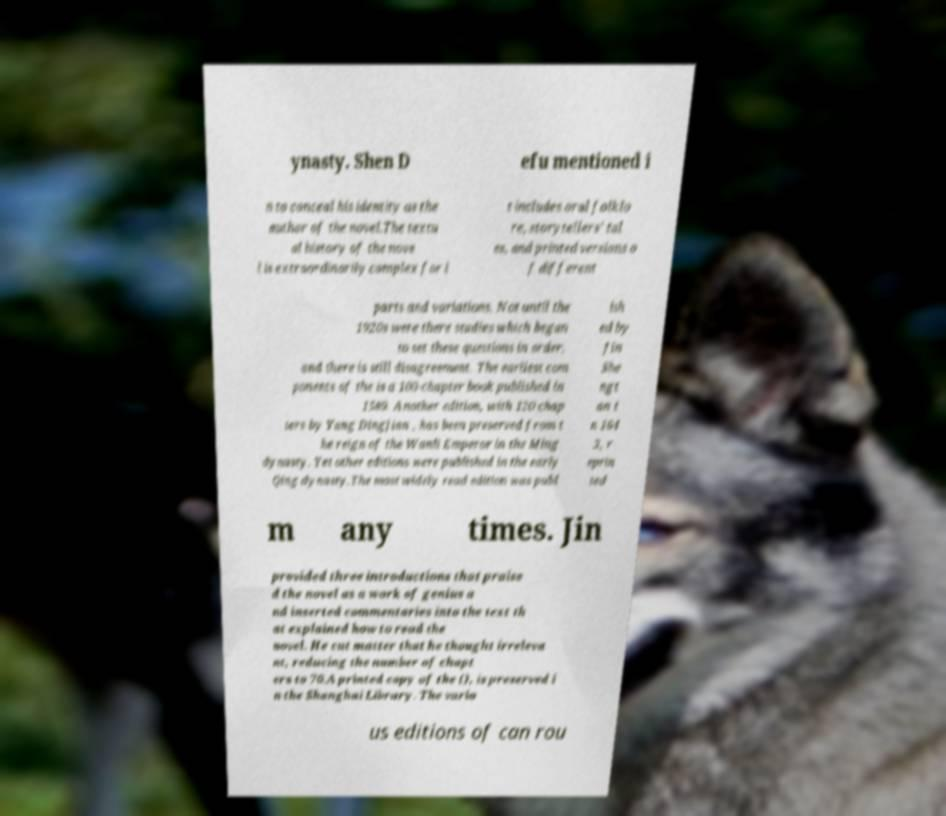Please identify and transcribe the text found in this image. ynasty. Shen D efu mentioned i n to conceal his identity as the author of the novel.The textu al history of the nove l is extraordinarily complex for i t includes oral folklo re, storytellers' tal es, and printed versions o f different parts and variations. Not until the 1920s were there studies which began to set these questions in order, and there is still disagreement. The earliest com ponents of the is a 100-chapter book published in 1589. Another edition, with 120 chap ters by Yang Dingjian , has been preserved from t he reign of the Wanli Emperor in the Ming dynasty. Yet other editions were published in the early Qing dynasty.The most widely read edition was publ ish ed by Jin She ngt an i n 164 3, r eprin ted m any times. Jin provided three introductions that praise d the novel as a work of genius a nd inserted commentaries into the text th at explained how to read the novel. He cut matter that he thought irreleva nt, reducing the number of chapt ers to 70.A printed copy of the (), is preserved i n the Shanghai Library. The vario us editions of can rou 